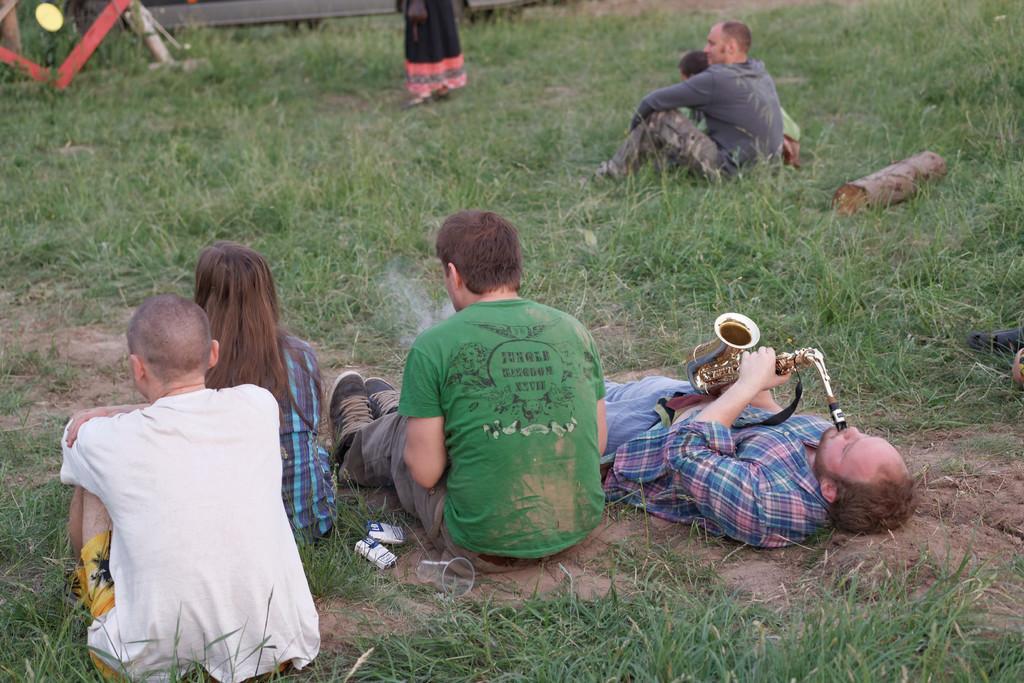How would you summarize this image in a sentence or two? In this image we can see some people sitting on the grass. And we can see a musical instrument in one of their hands. And we can see the glasses and some other objects on the grass. 